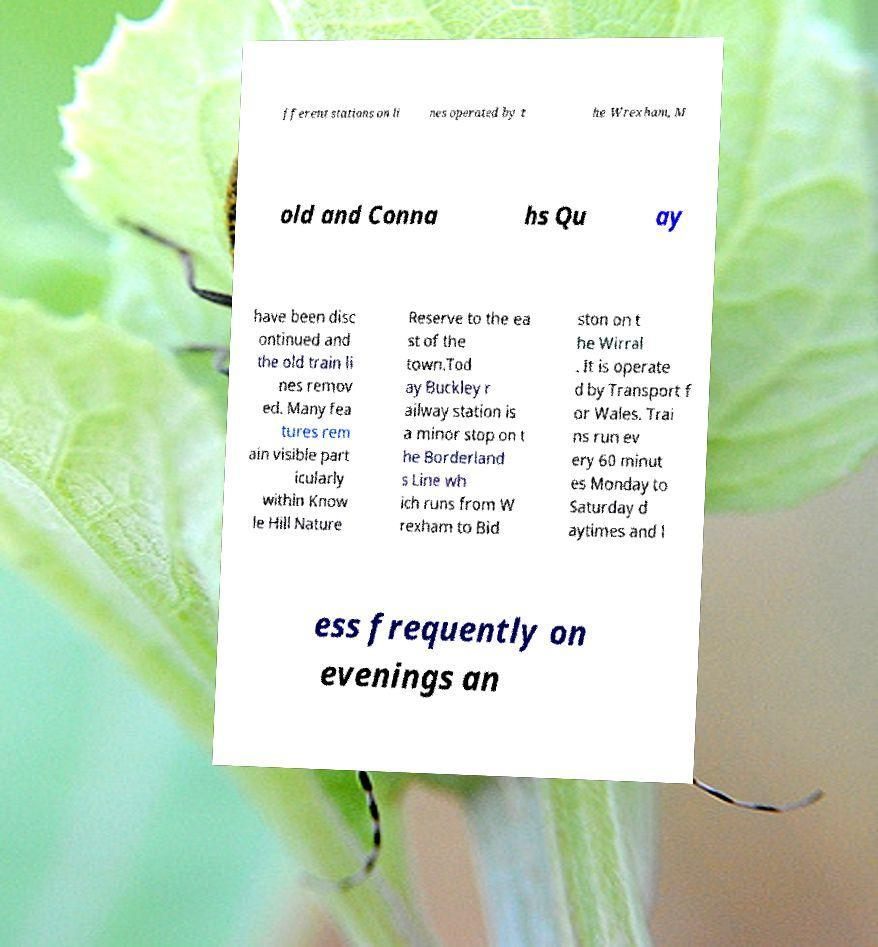I need the written content from this picture converted into text. Can you do that? fferent stations on li nes operated by t he Wrexham, M old and Conna hs Qu ay have been disc ontinued and the old train li nes remov ed. Many fea tures rem ain visible part icularly within Know le Hill Nature Reserve to the ea st of the town.Tod ay Buckley r ailway station is a minor stop on t he Borderland s Line wh ich runs from W rexham to Bid ston on t he Wirral . It is operate d by Transport f or Wales. Trai ns run ev ery 60 minut es Monday to Saturday d aytimes and l ess frequently on evenings an 